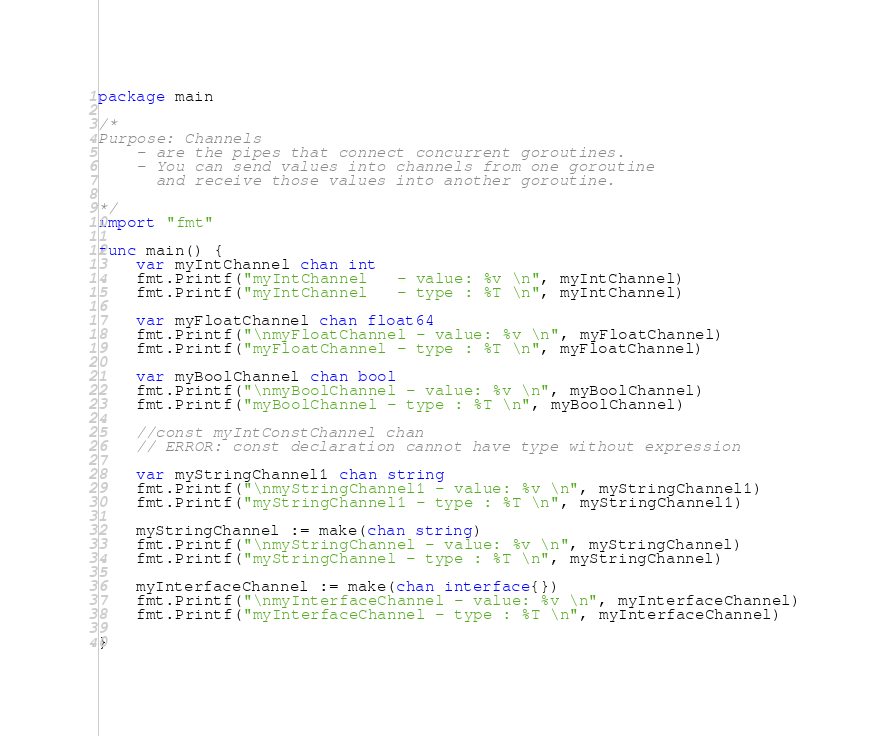<code> <loc_0><loc_0><loc_500><loc_500><_Go_>package main

/*
Purpose: Channels
	- are the pipes that connect concurrent goroutines.
	- You can send values into channels from one goroutine
      and receive those values into another goroutine.

*/
import "fmt"

func main() {
	var myIntChannel chan int
	fmt.Printf("myIntChannel   - value: %v \n", myIntChannel)
	fmt.Printf("myIntChannel   - type : %T \n", myIntChannel)

	var myFloatChannel chan float64
	fmt.Printf("\nmyFloatChannel - value: %v \n", myFloatChannel)
	fmt.Printf("myFloatChannel - type : %T \n", myFloatChannel)

	var myBoolChannel chan bool
	fmt.Printf("\nmyBoolChannel - value: %v \n", myBoolChannel)
	fmt.Printf("myBoolChannel - type : %T \n", myBoolChannel)

	//const myIntConstChannel chan
	// ERROR: const declaration cannot have type without expression

	var myStringChannel1 chan string
	fmt.Printf("\nmyStringChannel1 - value: %v \n", myStringChannel1)
	fmt.Printf("myStringChannel1 - type : %T \n", myStringChannel1)

	myStringChannel := make(chan string)
	fmt.Printf("\nmyStringChannel - value: %v \n", myStringChannel)
	fmt.Printf("myStringChannel - type : %T \n", myStringChannel)

	myInterfaceChannel := make(chan interface{})
	fmt.Printf("\nmyInterfaceChannel - value: %v \n", myInterfaceChannel)
	fmt.Printf("myInterfaceChannel - type : %T \n", myInterfaceChannel)

}
</code> 